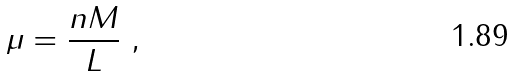Convert formula to latex. <formula><loc_0><loc_0><loc_500><loc_500>\mu = \frac { n M } { L } \ ,</formula> 